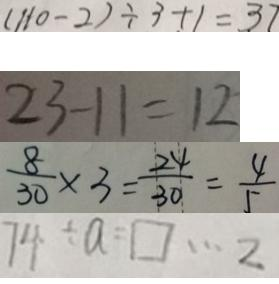Convert formula to latex. <formula><loc_0><loc_0><loc_500><loc_500>( 1 1 0 - 2 ) \div 3 + 1 = 3 7 
 2 3 - 1 1 = 1 2 
 \frac { 8 } { 3 0 } \times 3 = \frac { 2 4 } { 3 0 } = \frac { 4 } { 5 } 
 7 4 \div a = \square \cdots 2</formula> 